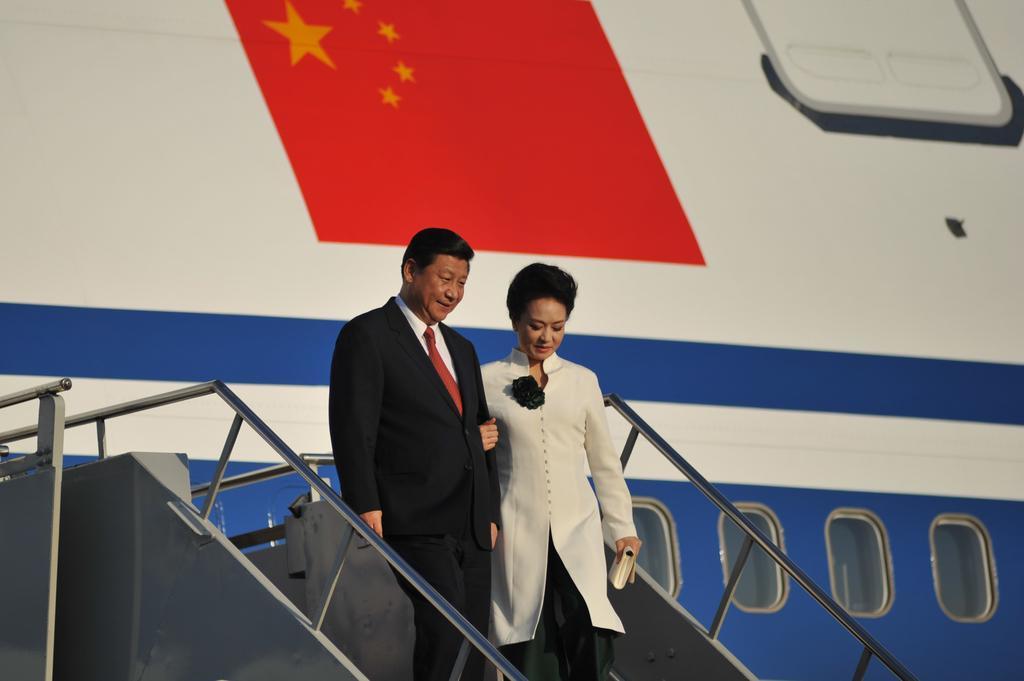Please provide a concise description of this image. A man is walking from the flight. He wore black color coat, trouser. Beside him there is a beautiful woman, she wore coat and also holding a purse in her left hand 